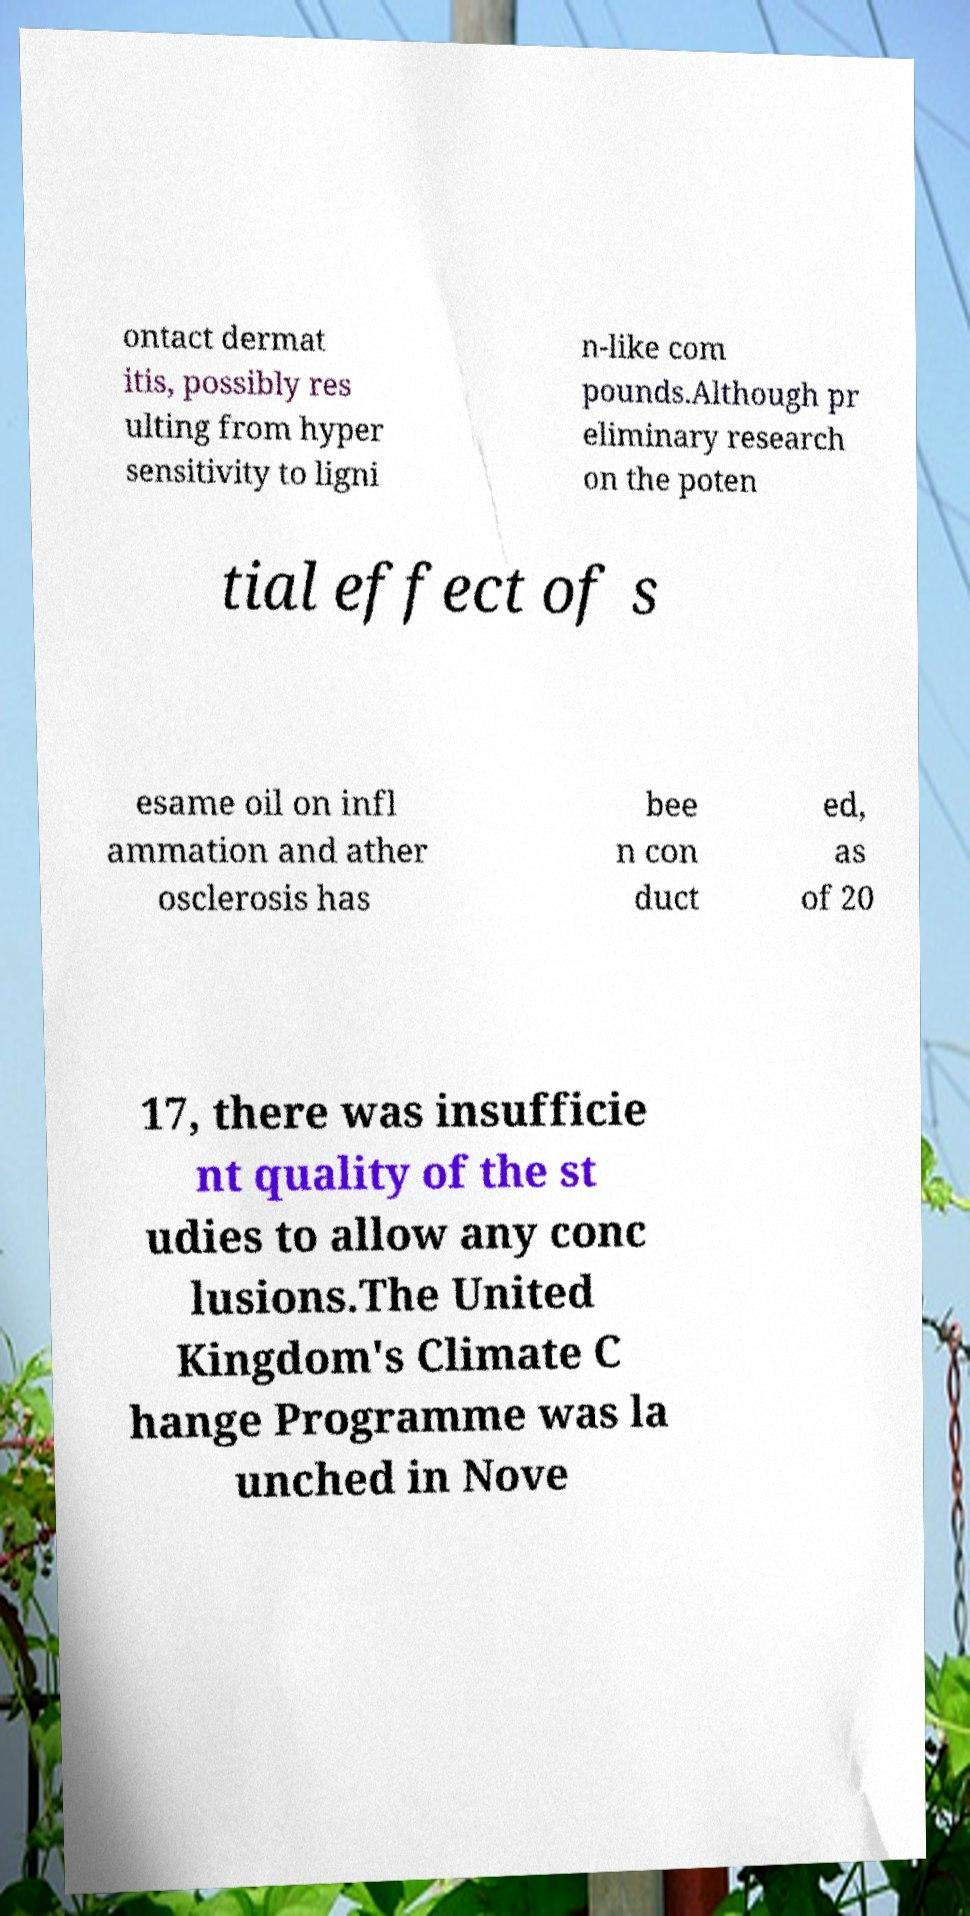There's text embedded in this image that I need extracted. Can you transcribe it verbatim? ontact dermat itis, possibly res ulting from hyper sensitivity to ligni n-like com pounds.Although pr eliminary research on the poten tial effect of s esame oil on infl ammation and ather osclerosis has bee n con duct ed, as of 20 17, there was insufficie nt quality of the st udies to allow any conc lusions.The United Kingdom's Climate C hange Programme was la unched in Nove 